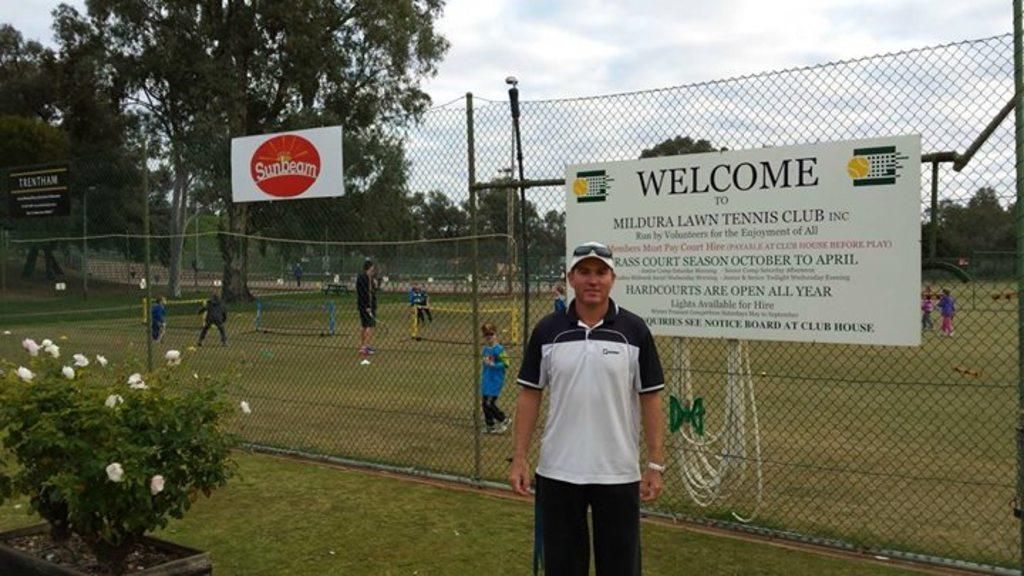<image>
Share a concise interpretation of the image provided. A big sign welcoming people to Mildura Lawn Tennis Club hands from a fence. 